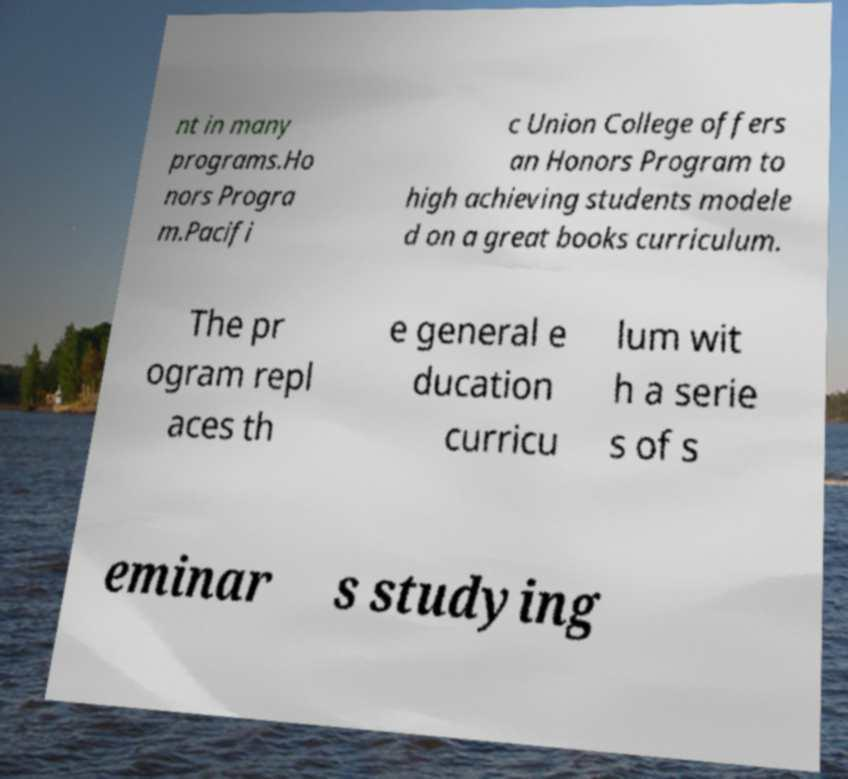Please identify and transcribe the text found in this image. nt in many programs.Ho nors Progra m.Pacifi c Union College offers an Honors Program to high achieving students modele d on a great books curriculum. The pr ogram repl aces th e general e ducation curricu lum wit h a serie s of s eminar s studying 